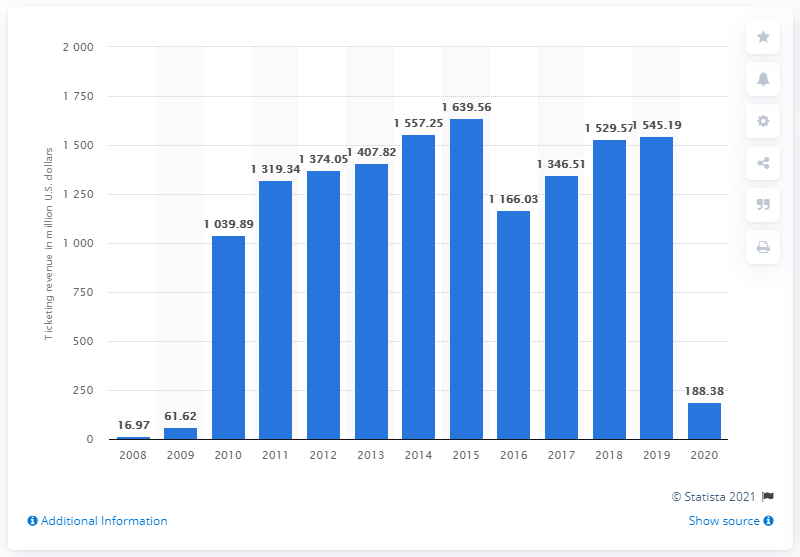Identify some key points in this picture. In 2020, Live Nation generated a total revenue of 188.38 million dollars. 